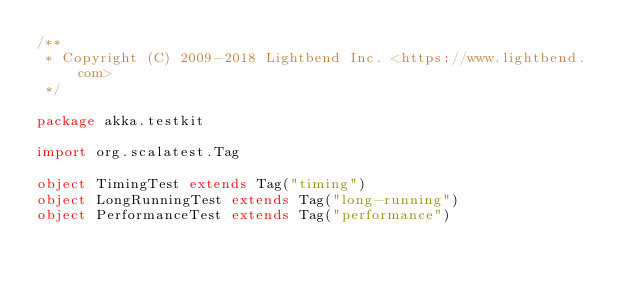Convert code to text. <code><loc_0><loc_0><loc_500><loc_500><_Scala_>/**
 * Copyright (C) 2009-2018 Lightbend Inc. <https://www.lightbend.com>
 */

package akka.testkit

import org.scalatest.Tag

object TimingTest extends Tag("timing")
object LongRunningTest extends Tag("long-running")
object PerformanceTest extends Tag("performance")
</code> 